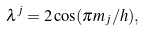<formula> <loc_0><loc_0><loc_500><loc_500>\lambda ^ { j } = 2 \cos ( \pi m _ { j } / h ) ,</formula> 